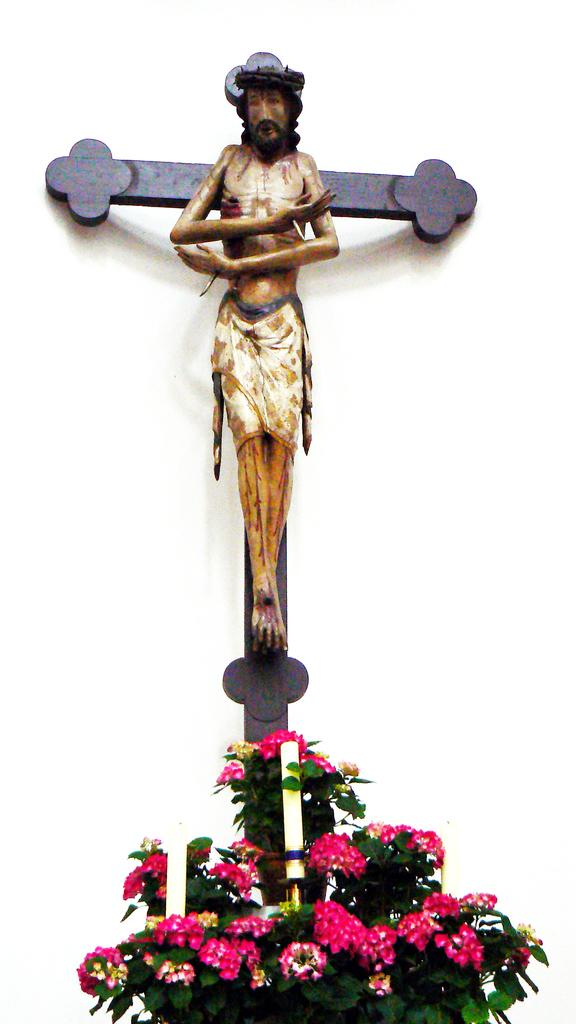What is the main subject of the image? There is a statue of Jesus in the image. What type of flowers can be seen in the image? There are red color flowers in the image. What is the color of the background in the image? The background of the image is white in color. How many apples are present in the image? There are no apples present in the image. What type of waste can be seen in the image? There is no waste visible in the image. 